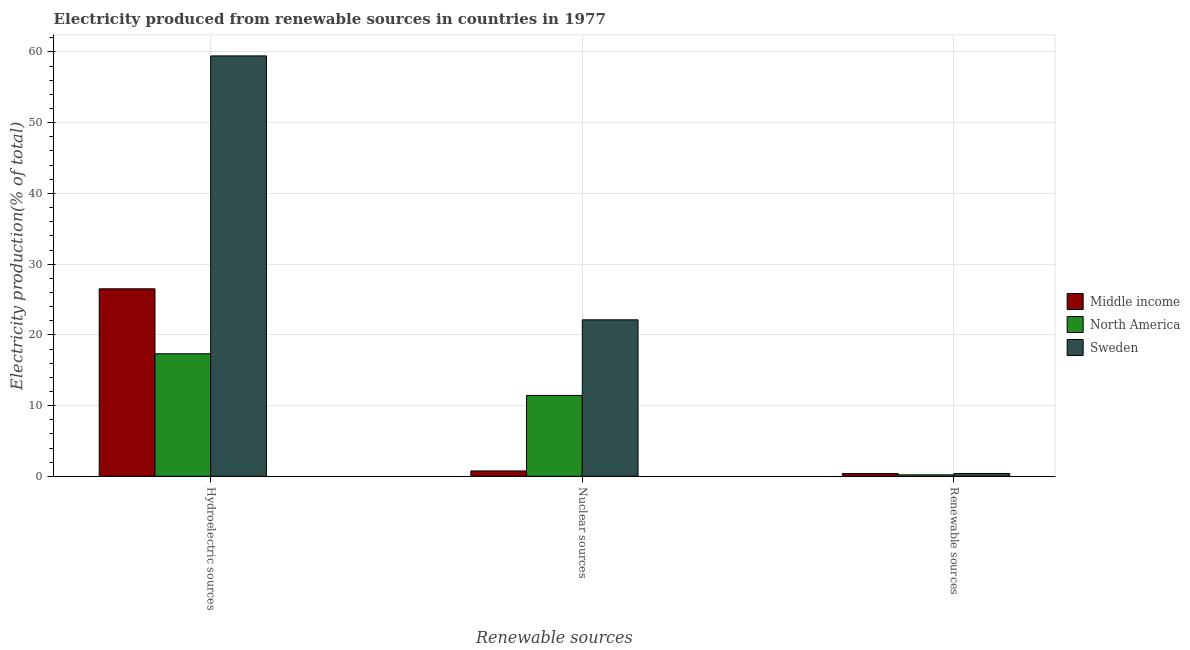How many bars are there on the 1st tick from the left?
Provide a short and direct response. 3. What is the label of the 1st group of bars from the left?
Your answer should be compact. Hydroelectric sources. What is the percentage of electricity produced by renewable sources in Middle income?
Offer a very short reply. 0.39. Across all countries, what is the maximum percentage of electricity produced by hydroelectric sources?
Give a very brief answer. 59.45. Across all countries, what is the minimum percentage of electricity produced by renewable sources?
Provide a succinct answer. 0.21. In which country was the percentage of electricity produced by nuclear sources maximum?
Keep it short and to the point. Sweden. What is the total percentage of electricity produced by renewable sources in the graph?
Your answer should be compact. 1. What is the difference between the percentage of electricity produced by hydroelectric sources in Sweden and that in Middle income?
Make the answer very short. 32.93. What is the difference between the percentage of electricity produced by hydroelectric sources in North America and the percentage of electricity produced by nuclear sources in Sweden?
Provide a short and direct response. -4.8. What is the average percentage of electricity produced by nuclear sources per country?
Your response must be concise. 11.44. What is the difference between the percentage of electricity produced by hydroelectric sources and percentage of electricity produced by renewable sources in North America?
Offer a terse response. 17.12. What is the ratio of the percentage of electricity produced by renewable sources in Sweden to that in Middle income?
Make the answer very short. 1.01. Is the percentage of electricity produced by hydroelectric sources in North America less than that in Middle income?
Provide a succinct answer. Yes. Is the difference between the percentage of electricity produced by renewable sources in North America and Sweden greater than the difference between the percentage of electricity produced by hydroelectric sources in North America and Sweden?
Your answer should be compact. Yes. What is the difference between the highest and the second highest percentage of electricity produced by renewable sources?
Your answer should be compact. 0.01. What is the difference between the highest and the lowest percentage of electricity produced by hydroelectric sources?
Give a very brief answer. 42.12. In how many countries, is the percentage of electricity produced by hydroelectric sources greater than the average percentage of electricity produced by hydroelectric sources taken over all countries?
Give a very brief answer. 1. Is the sum of the percentage of electricity produced by nuclear sources in Sweden and Middle income greater than the maximum percentage of electricity produced by hydroelectric sources across all countries?
Provide a succinct answer. No. What does the 3rd bar from the left in Hydroelectric sources represents?
Provide a short and direct response. Sweden. What does the 3rd bar from the right in Renewable sources represents?
Your answer should be compact. Middle income. Are all the bars in the graph horizontal?
Provide a succinct answer. No. What is the difference between two consecutive major ticks on the Y-axis?
Offer a very short reply. 10. Does the graph contain any zero values?
Keep it short and to the point. No. How many legend labels are there?
Offer a very short reply. 3. What is the title of the graph?
Your response must be concise. Electricity produced from renewable sources in countries in 1977. What is the label or title of the X-axis?
Your answer should be compact. Renewable sources. What is the Electricity production(% of total) of Middle income in Hydroelectric sources?
Offer a very short reply. 26.51. What is the Electricity production(% of total) in North America in Hydroelectric sources?
Provide a succinct answer. 17.33. What is the Electricity production(% of total) in Sweden in Hydroelectric sources?
Offer a very short reply. 59.45. What is the Electricity production(% of total) of Middle income in Nuclear sources?
Ensure brevity in your answer.  0.76. What is the Electricity production(% of total) of North America in Nuclear sources?
Offer a very short reply. 11.44. What is the Electricity production(% of total) in Sweden in Nuclear sources?
Give a very brief answer. 22.13. What is the Electricity production(% of total) of Middle income in Renewable sources?
Offer a very short reply. 0.39. What is the Electricity production(% of total) in North America in Renewable sources?
Offer a very short reply. 0.21. What is the Electricity production(% of total) in Sweden in Renewable sources?
Give a very brief answer. 0.4. Across all Renewable sources, what is the maximum Electricity production(% of total) in Middle income?
Your answer should be compact. 26.51. Across all Renewable sources, what is the maximum Electricity production(% of total) in North America?
Offer a terse response. 17.33. Across all Renewable sources, what is the maximum Electricity production(% of total) of Sweden?
Your response must be concise. 59.45. Across all Renewable sources, what is the minimum Electricity production(% of total) of Middle income?
Your answer should be very brief. 0.39. Across all Renewable sources, what is the minimum Electricity production(% of total) of North America?
Your response must be concise. 0.21. Across all Renewable sources, what is the minimum Electricity production(% of total) of Sweden?
Your response must be concise. 0.4. What is the total Electricity production(% of total) in Middle income in the graph?
Provide a short and direct response. 27.67. What is the total Electricity production(% of total) of North America in the graph?
Your response must be concise. 28.97. What is the total Electricity production(% of total) in Sweden in the graph?
Give a very brief answer. 81.97. What is the difference between the Electricity production(% of total) in Middle income in Hydroelectric sources and that in Nuclear sources?
Keep it short and to the point. 25.75. What is the difference between the Electricity production(% of total) in North America in Hydroelectric sources and that in Nuclear sources?
Keep it short and to the point. 5.89. What is the difference between the Electricity production(% of total) of Sweden in Hydroelectric sources and that in Nuclear sources?
Provide a short and direct response. 37.32. What is the difference between the Electricity production(% of total) in Middle income in Hydroelectric sources and that in Renewable sources?
Offer a terse response. 26.12. What is the difference between the Electricity production(% of total) of North America in Hydroelectric sources and that in Renewable sources?
Offer a terse response. 17.12. What is the difference between the Electricity production(% of total) in Sweden in Hydroelectric sources and that in Renewable sources?
Make the answer very short. 59.05. What is the difference between the Electricity production(% of total) of Middle income in Nuclear sources and that in Renewable sources?
Provide a short and direct response. 0.36. What is the difference between the Electricity production(% of total) in North America in Nuclear sources and that in Renewable sources?
Make the answer very short. 11.23. What is the difference between the Electricity production(% of total) in Sweden in Nuclear sources and that in Renewable sources?
Provide a short and direct response. 21.73. What is the difference between the Electricity production(% of total) in Middle income in Hydroelectric sources and the Electricity production(% of total) in North America in Nuclear sources?
Keep it short and to the point. 15.08. What is the difference between the Electricity production(% of total) in Middle income in Hydroelectric sources and the Electricity production(% of total) in Sweden in Nuclear sources?
Offer a very short reply. 4.39. What is the difference between the Electricity production(% of total) of North America in Hydroelectric sources and the Electricity production(% of total) of Sweden in Nuclear sources?
Offer a very short reply. -4.8. What is the difference between the Electricity production(% of total) of Middle income in Hydroelectric sources and the Electricity production(% of total) of North America in Renewable sources?
Offer a very short reply. 26.3. What is the difference between the Electricity production(% of total) of Middle income in Hydroelectric sources and the Electricity production(% of total) of Sweden in Renewable sources?
Ensure brevity in your answer.  26.11. What is the difference between the Electricity production(% of total) in North America in Hydroelectric sources and the Electricity production(% of total) in Sweden in Renewable sources?
Offer a terse response. 16.93. What is the difference between the Electricity production(% of total) of Middle income in Nuclear sources and the Electricity production(% of total) of North America in Renewable sources?
Keep it short and to the point. 0.55. What is the difference between the Electricity production(% of total) of Middle income in Nuclear sources and the Electricity production(% of total) of Sweden in Renewable sources?
Ensure brevity in your answer.  0.36. What is the difference between the Electricity production(% of total) of North America in Nuclear sources and the Electricity production(% of total) of Sweden in Renewable sources?
Your response must be concise. 11.04. What is the average Electricity production(% of total) of Middle income per Renewable sources?
Your response must be concise. 9.22. What is the average Electricity production(% of total) of North America per Renewable sources?
Your response must be concise. 9.66. What is the average Electricity production(% of total) of Sweden per Renewable sources?
Ensure brevity in your answer.  27.32. What is the difference between the Electricity production(% of total) of Middle income and Electricity production(% of total) of North America in Hydroelectric sources?
Offer a terse response. 9.19. What is the difference between the Electricity production(% of total) in Middle income and Electricity production(% of total) in Sweden in Hydroelectric sources?
Keep it short and to the point. -32.93. What is the difference between the Electricity production(% of total) in North America and Electricity production(% of total) in Sweden in Hydroelectric sources?
Your response must be concise. -42.12. What is the difference between the Electricity production(% of total) in Middle income and Electricity production(% of total) in North America in Nuclear sources?
Your answer should be compact. -10.68. What is the difference between the Electricity production(% of total) of Middle income and Electricity production(% of total) of Sweden in Nuclear sources?
Give a very brief answer. -21.37. What is the difference between the Electricity production(% of total) of North America and Electricity production(% of total) of Sweden in Nuclear sources?
Keep it short and to the point. -10.69. What is the difference between the Electricity production(% of total) in Middle income and Electricity production(% of total) in North America in Renewable sources?
Offer a very short reply. 0.19. What is the difference between the Electricity production(% of total) of Middle income and Electricity production(% of total) of Sweden in Renewable sources?
Ensure brevity in your answer.  -0.01. What is the difference between the Electricity production(% of total) of North America and Electricity production(% of total) of Sweden in Renewable sources?
Your answer should be very brief. -0.19. What is the ratio of the Electricity production(% of total) in Middle income in Hydroelectric sources to that in Nuclear sources?
Your response must be concise. 34.9. What is the ratio of the Electricity production(% of total) of North America in Hydroelectric sources to that in Nuclear sources?
Ensure brevity in your answer.  1.51. What is the ratio of the Electricity production(% of total) of Sweden in Hydroelectric sources to that in Nuclear sources?
Ensure brevity in your answer.  2.69. What is the ratio of the Electricity production(% of total) of Middle income in Hydroelectric sources to that in Renewable sources?
Your answer should be very brief. 67.14. What is the ratio of the Electricity production(% of total) of North America in Hydroelectric sources to that in Renewable sources?
Offer a very short reply. 82.69. What is the ratio of the Electricity production(% of total) of Sweden in Hydroelectric sources to that in Renewable sources?
Make the answer very short. 148.6. What is the ratio of the Electricity production(% of total) in Middle income in Nuclear sources to that in Renewable sources?
Keep it short and to the point. 1.92. What is the ratio of the Electricity production(% of total) in North America in Nuclear sources to that in Renewable sources?
Your response must be concise. 54.58. What is the ratio of the Electricity production(% of total) of Sweden in Nuclear sources to that in Renewable sources?
Your answer should be very brief. 55.31. What is the difference between the highest and the second highest Electricity production(% of total) in Middle income?
Make the answer very short. 25.75. What is the difference between the highest and the second highest Electricity production(% of total) in North America?
Give a very brief answer. 5.89. What is the difference between the highest and the second highest Electricity production(% of total) in Sweden?
Offer a terse response. 37.32. What is the difference between the highest and the lowest Electricity production(% of total) of Middle income?
Your answer should be very brief. 26.12. What is the difference between the highest and the lowest Electricity production(% of total) of North America?
Provide a short and direct response. 17.12. What is the difference between the highest and the lowest Electricity production(% of total) in Sweden?
Provide a succinct answer. 59.05. 